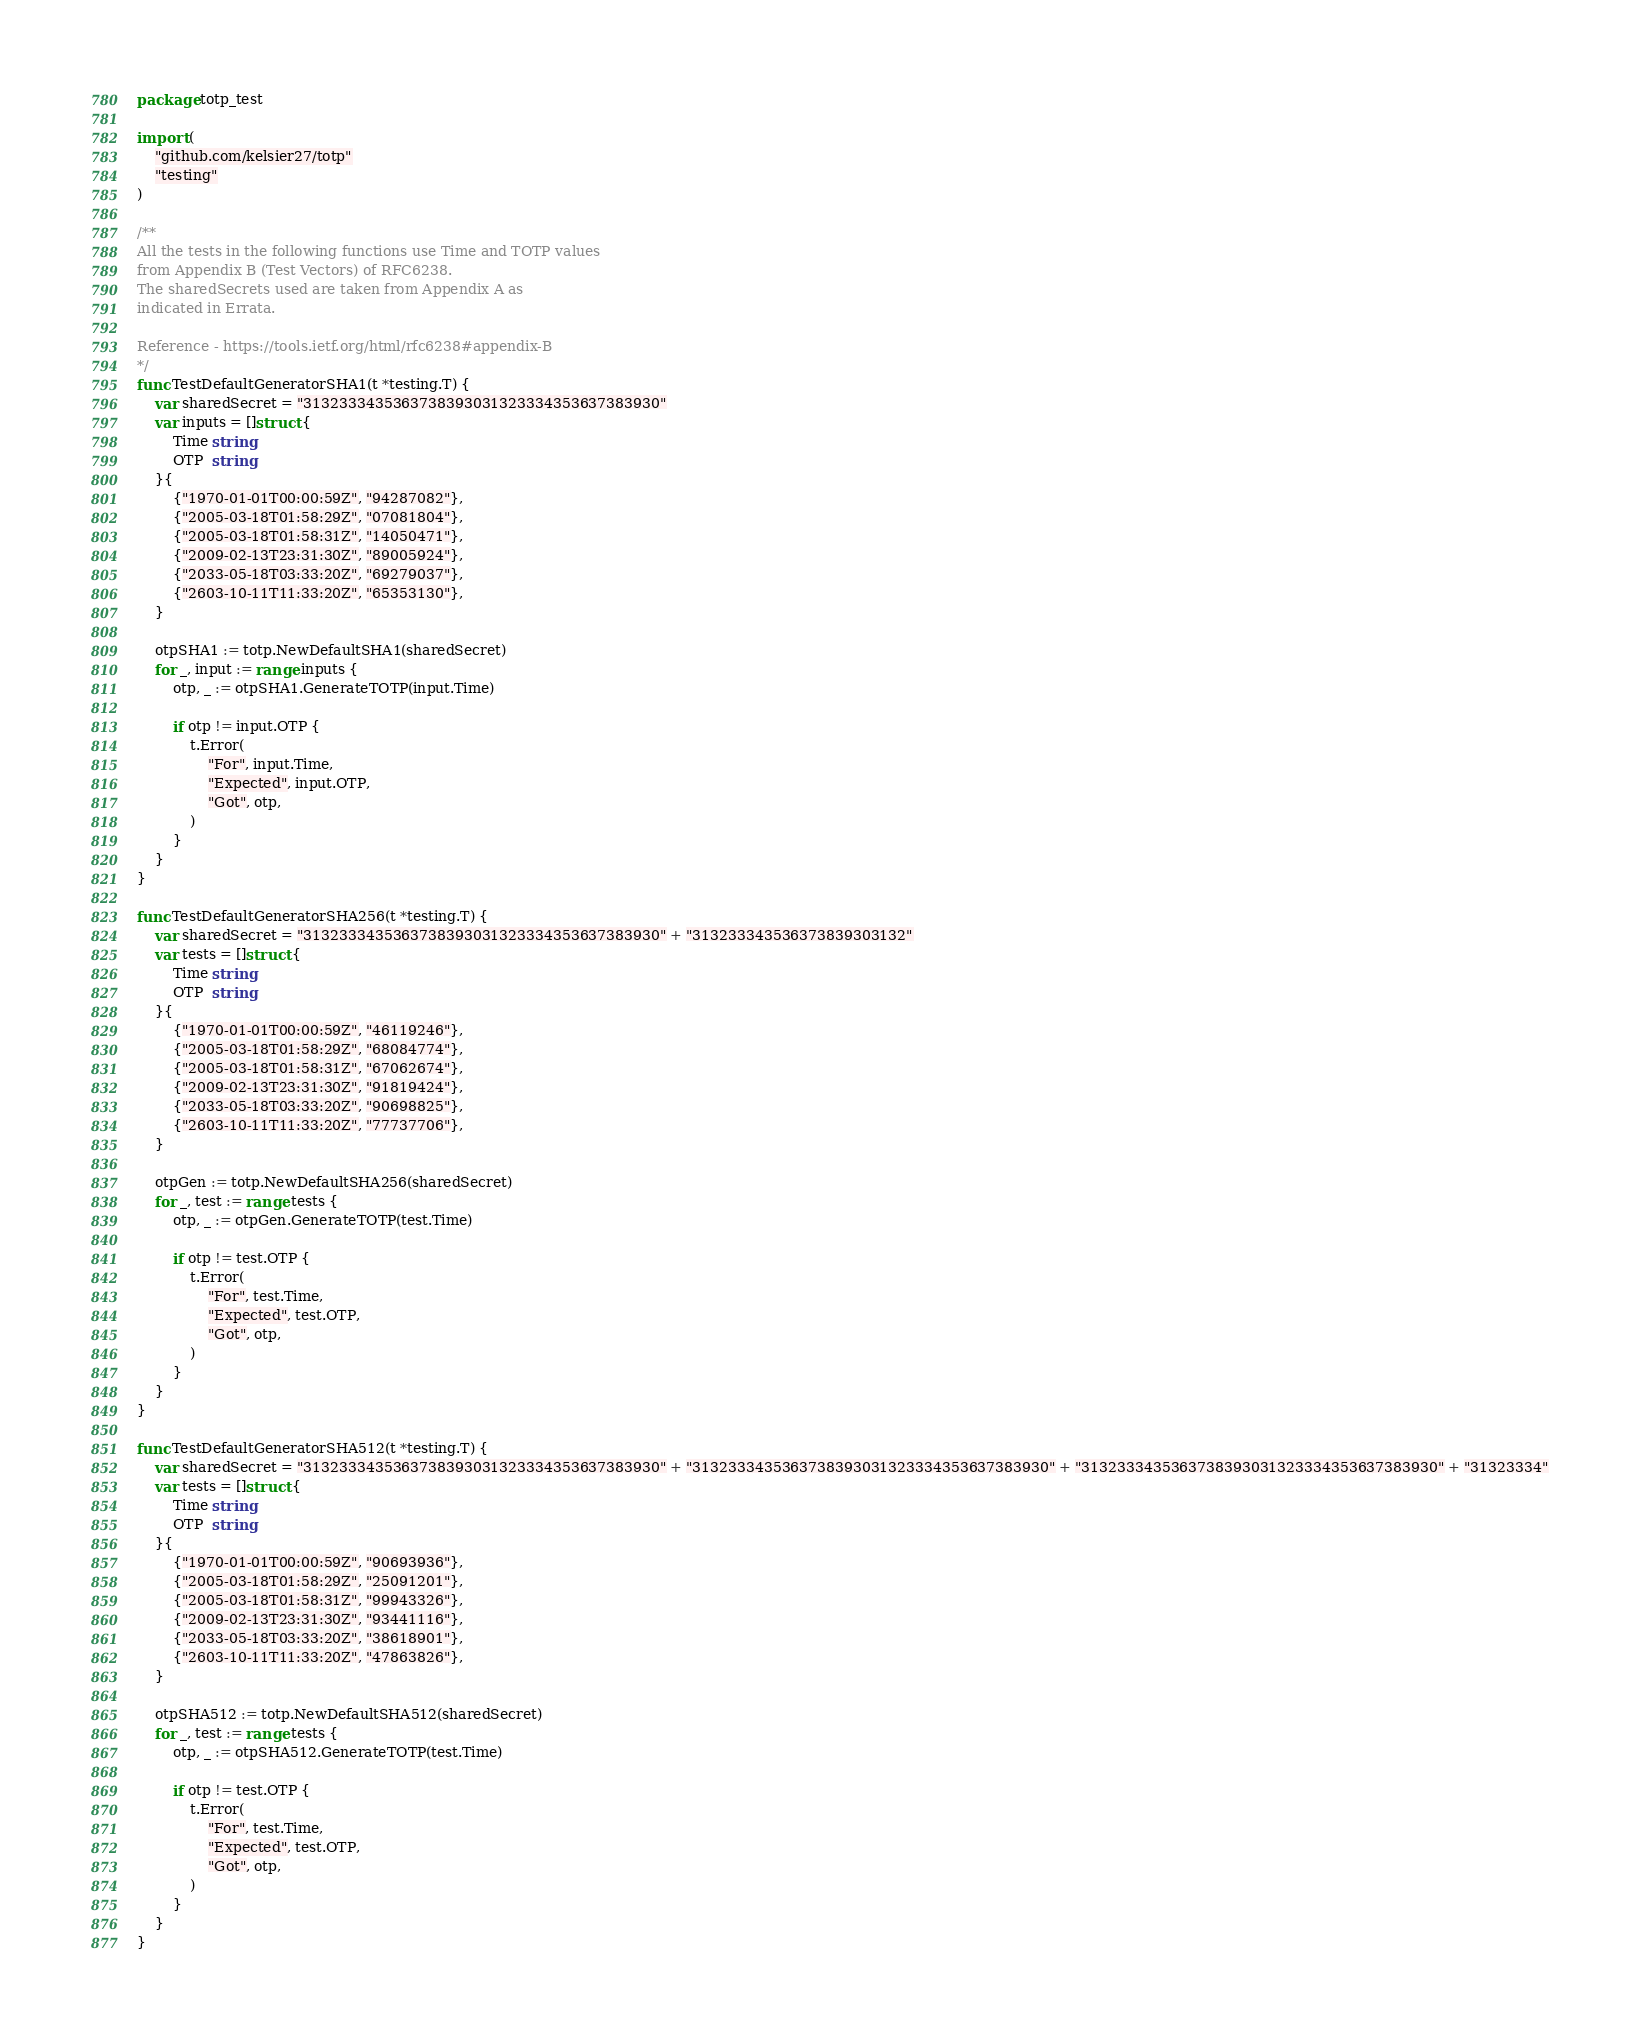<code> <loc_0><loc_0><loc_500><loc_500><_Go_>package totp_test

import (
	"github.com/kelsier27/totp"
	"testing"
)

/**
All the tests in the following functions use Time and TOTP values
from Appendix B (Test Vectors) of RFC6238.
The sharedSecrets used are taken from Appendix A as
indicated in Errata.

Reference - https://tools.ietf.org/html/rfc6238#appendix-B
*/
func TestDefaultGeneratorSHA1(t *testing.T) {
	var sharedSecret = "3132333435363738393031323334353637383930"
	var inputs = []struct {
		Time string
		OTP  string
	}{
		{"1970-01-01T00:00:59Z", "94287082"},
		{"2005-03-18T01:58:29Z", "07081804"},
		{"2005-03-18T01:58:31Z", "14050471"},
		{"2009-02-13T23:31:30Z", "89005924"},
		{"2033-05-18T03:33:20Z", "69279037"},
		{"2603-10-11T11:33:20Z", "65353130"},
	}

	otpSHA1 := totp.NewDefaultSHA1(sharedSecret)
	for _, input := range inputs {
		otp, _ := otpSHA1.GenerateTOTP(input.Time)

		if otp != input.OTP {
			t.Error(
				"For", input.Time,
				"Expected", input.OTP,
				"Got", otp,
			)
		}
	}
}

func TestDefaultGeneratorSHA256(t *testing.T) {
	var sharedSecret = "3132333435363738393031323334353637383930" + "313233343536373839303132"
	var tests = []struct {
		Time string
		OTP  string
	}{
		{"1970-01-01T00:00:59Z", "46119246"},
		{"2005-03-18T01:58:29Z", "68084774"},
		{"2005-03-18T01:58:31Z", "67062674"},
		{"2009-02-13T23:31:30Z", "91819424"},
		{"2033-05-18T03:33:20Z", "90698825"},
		{"2603-10-11T11:33:20Z", "77737706"},
	}

	otpGen := totp.NewDefaultSHA256(sharedSecret)
	for _, test := range tests {
		otp, _ := otpGen.GenerateTOTP(test.Time)

		if otp != test.OTP {
			t.Error(
				"For", test.Time,
				"Expected", test.OTP,
				"Got", otp,
			)
		}
	}
}

func TestDefaultGeneratorSHA512(t *testing.T) {
	var sharedSecret = "3132333435363738393031323334353637383930" + "3132333435363738393031323334353637383930" + "3132333435363738393031323334353637383930" + "31323334"
	var tests = []struct {
		Time string
		OTP  string
	}{
		{"1970-01-01T00:00:59Z", "90693936"},
		{"2005-03-18T01:58:29Z", "25091201"},
		{"2005-03-18T01:58:31Z", "99943326"},
		{"2009-02-13T23:31:30Z", "93441116"},
		{"2033-05-18T03:33:20Z", "38618901"},
		{"2603-10-11T11:33:20Z", "47863826"},
	}

	otpSHA512 := totp.NewDefaultSHA512(sharedSecret)
	for _, test := range tests {
		otp, _ := otpSHA512.GenerateTOTP(test.Time)

		if otp != test.OTP {
			t.Error(
				"For", test.Time,
				"Expected", test.OTP,
				"Got", otp,
			)
		}
	}
}
</code> 